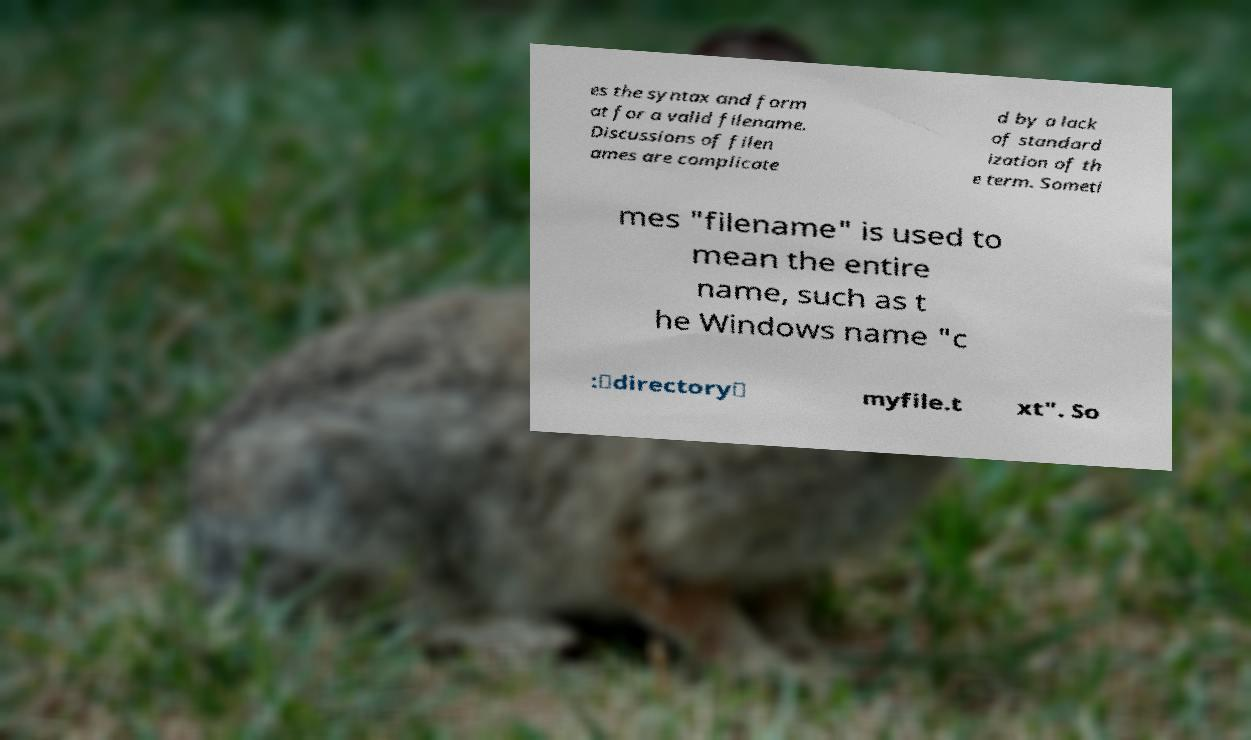Could you extract and type out the text from this image? es the syntax and form at for a valid filename. Discussions of filen ames are complicate d by a lack of standard ization of th e term. Someti mes "filename" is used to mean the entire name, such as t he Windows name "c :\directory\ myfile.t xt". So 